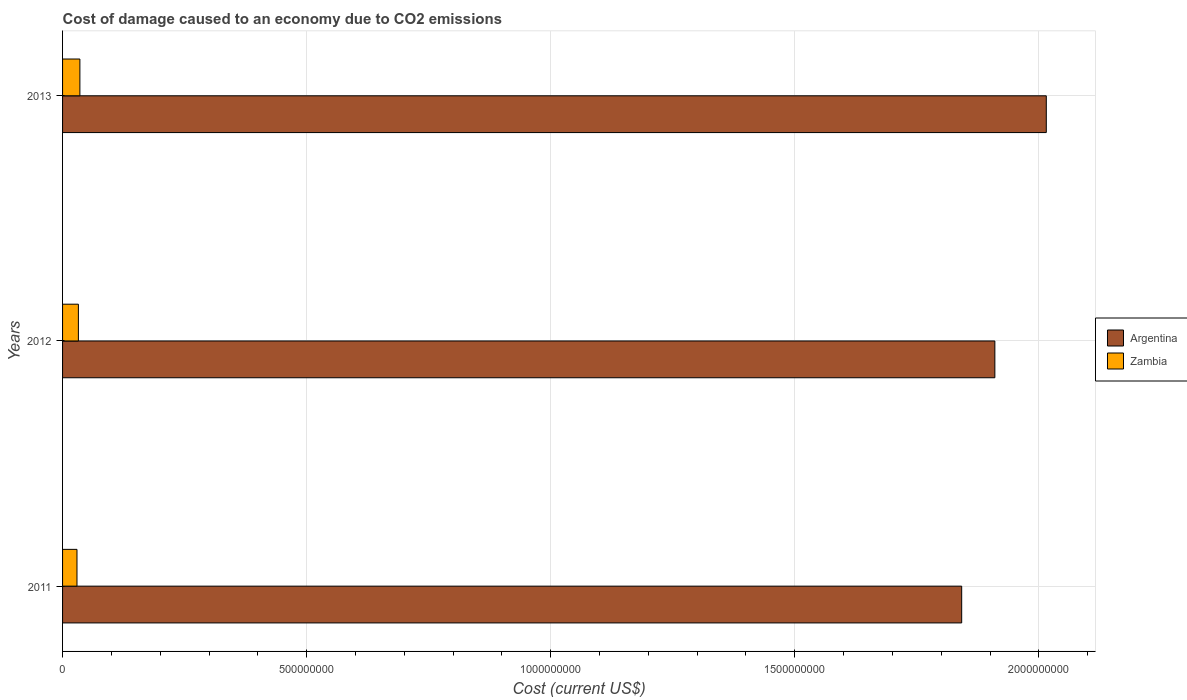How many different coloured bars are there?
Provide a short and direct response. 2. How many groups of bars are there?
Your answer should be compact. 3. Are the number of bars per tick equal to the number of legend labels?
Offer a terse response. Yes. How many bars are there on the 1st tick from the top?
Keep it short and to the point. 2. What is the cost of damage caused due to CO2 emissisons in Argentina in 2011?
Provide a short and direct response. 1.84e+09. Across all years, what is the maximum cost of damage caused due to CO2 emissisons in Argentina?
Give a very brief answer. 2.02e+09. Across all years, what is the minimum cost of damage caused due to CO2 emissisons in Zambia?
Make the answer very short. 2.95e+07. In which year was the cost of damage caused due to CO2 emissisons in Zambia maximum?
Offer a terse response. 2013. What is the total cost of damage caused due to CO2 emissisons in Argentina in the graph?
Make the answer very short. 5.77e+09. What is the difference between the cost of damage caused due to CO2 emissisons in Zambia in 2011 and that in 2013?
Offer a very short reply. -5.95e+06. What is the difference between the cost of damage caused due to CO2 emissisons in Argentina in 2011 and the cost of damage caused due to CO2 emissisons in Zambia in 2012?
Give a very brief answer. 1.81e+09. What is the average cost of damage caused due to CO2 emissisons in Zambia per year?
Keep it short and to the point. 3.25e+07. In the year 2011, what is the difference between the cost of damage caused due to CO2 emissisons in Argentina and cost of damage caused due to CO2 emissisons in Zambia?
Ensure brevity in your answer.  1.81e+09. What is the ratio of the cost of damage caused due to CO2 emissisons in Argentina in 2011 to that in 2012?
Keep it short and to the point. 0.96. Is the difference between the cost of damage caused due to CO2 emissisons in Argentina in 2011 and 2013 greater than the difference between the cost of damage caused due to CO2 emissisons in Zambia in 2011 and 2013?
Your answer should be very brief. No. What is the difference between the highest and the second highest cost of damage caused due to CO2 emissisons in Zambia?
Provide a short and direct response. 3.06e+06. What is the difference between the highest and the lowest cost of damage caused due to CO2 emissisons in Argentina?
Give a very brief answer. 1.73e+08. Is the sum of the cost of damage caused due to CO2 emissisons in Argentina in 2011 and 2013 greater than the maximum cost of damage caused due to CO2 emissisons in Zambia across all years?
Your answer should be very brief. Yes. What does the 2nd bar from the top in 2012 represents?
Give a very brief answer. Argentina. What does the 2nd bar from the bottom in 2013 represents?
Give a very brief answer. Zambia. How many years are there in the graph?
Provide a succinct answer. 3. What is the difference between two consecutive major ticks on the X-axis?
Provide a succinct answer. 5.00e+08. Are the values on the major ticks of X-axis written in scientific E-notation?
Provide a short and direct response. No. Where does the legend appear in the graph?
Provide a short and direct response. Center right. How are the legend labels stacked?
Make the answer very short. Vertical. What is the title of the graph?
Keep it short and to the point. Cost of damage caused to an economy due to CO2 emissions. What is the label or title of the X-axis?
Give a very brief answer. Cost (current US$). What is the Cost (current US$) in Argentina in 2011?
Provide a short and direct response. 1.84e+09. What is the Cost (current US$) in Zambia in 2011?
Provide a succinct answer. 2.95e+07. What is the Cost (current US$) in Argentina in 2012?
Keep it short and to the point. 1.91e+09. What is the Cost (current US$) of Zambia in 2012?
Provide a short and direct response. 3.24e+07. What is the Cost (current US$) in Argentina in 2013?
Provide a short and direct response. 2.02e+09. What is the Cost (current US$) of Zambia in 2013?
Offer a terse response. 3.55e+07. Across all years, what is the maximum Cost (current US$) of Argentina?
Keep it short and to the point. 2.02e+09. Across all years, what is the maximum Cost (current US$) of Zambia?
Your response must be concise. 3.55e+07. Across all years, what is the minimum Cost (current US$) in Argentina?
Your response must be concise. 1.84e+09. Across all years, what is the minimum Cost (current US$) of Zambia?
Make the answer very short. 2.95e+07. What is the total Cost (current US$) of Argentina in the graph?
Ensure brevity in your answer.  5.77e+09. What is the total Cost (current US$) in Zambia in the graph?
Offer a very short reply. 9.75e+07. What is the difference between the Cost (current US$) in Argentina in 2011 and that in 2012?
Provide a short and direct response. -6.80e+07. What is the difference between the Cost (current US$) of Zambia in 2011 and that in 2012?
Provide a succinct answer. -2.89e+06. What is the difference between the Cost (current US$) of Argentina in 2011 and that in 2013?
Keep it short and to the point. -1.73e+08. What is the difference between the Cost (current US$) in Zambia in 2011 and that in 2013?
Provide a succinct answer. -5.95e+06. What is the difference between the Cost (current US$) in Argentina in 2012 and that in 2013?
Your response must be concise. -1.05e+08. What is the difference between the Cost (current US$) of Zambia in 2012 and that in 2013?
Give a very brief answer. -3.06e+06. What is the difference between the Cost (current US$) of Argentina in 2011 and the Cost (current US$) of Zambia in 2012?
Give a very brief answer. 1.81e+09. What is the difference between the Cost (current US$) of Argentina in 2011 and the Cost (current US$) of Zambia in 2013?
Give a very brief answer. 1.81e+09. What is the difference between the Cost (current US$) in Argentina in 2012 and the Cost (current US$) in Zambia in 2013?
Give a very brief answer. 1.87e+09. What is the average Cost (current US$) in Argentina per year?
Make the answer very short. 1.92e+09. What is the average Cost (current US$) in Zambia per year?
Make the answer very short. 3.25e+07. In the year 2011, what is the difference between the Cost (current US$) in Argentina and Cost (current US$) in Zambia?
Make the answer very short. 1.81e+09. In the year 2012, what is the difference between the Cost (current US$) in Argentina and Cost (current US$) in Zambia?
Your answer should be compact. 1.88e+09. In the year 2013, what is the difference between the Cost (current US$) in Argentina and Cost (current US$) in Zambia?
Your answer should be very brief. 1.98e+09. What is the ratio of the Cost (current US$) in Argentina in 2011 to that in 2012?
Make the answer very short. 0.96. What is the ratio of the Cost (current US$) of Zambia in 2011 to that in 2012?
Provide a succinct answer. 0.91. What is the ratio of the Cost (current US$) in Argentina in 2011 to that in 2013?
Your response must be concise. 0.91. What is the ratio of the Cost (current US$) in Zambia in 2011 to that in 2013?
Your answer should be very brief. 0.83. What is the ratio of the Cost (current US$) in Argentina in 2012 to that in 2013?
Make the answer very short. 0.95. What is the ratio of the Cost (current US$) in Zambia in 2012 to that in 2013?
Make the answer very short. 0.91. What is the difference between the highest and the second highest Cost (current US$) of Argentina?
Your response must be concise. 1.05e+08. What is the difference between the highest and the second highest Cost (current US$) of Zambia?
Your answer should be compact. 3.06e+06. What is the difference between the highest and the lowest Cost (current US$) of Argentina?
Provide a succinct answer. 1.73e+08. What is the difference between the highest and the lowest Cost (current US$) in Zambia?
Your answer should be very brief. 5.95e+06. 